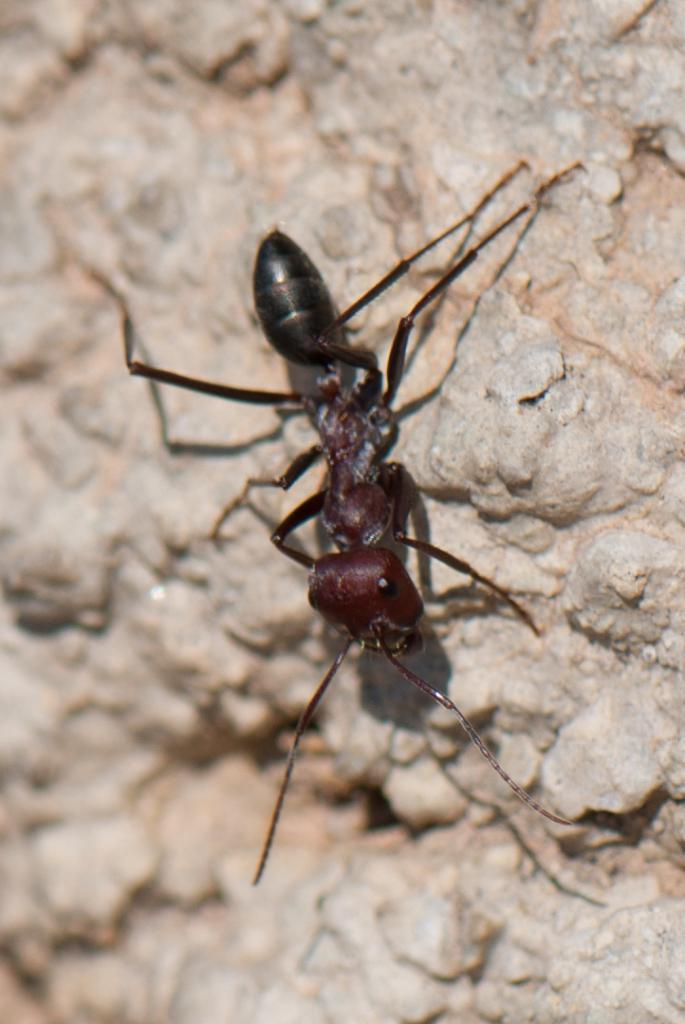What is the main subject of the image? The main subject of the image is an ant. Can you describe the ant's appearance? The ant is black in color. What can be seen in the background of the image? There is a rock or wall made up of stones in the background of the image. How is the background of the image depicted? The background of the image is blurred. What type of destruction is the grandfather causing with a hammer in the image? There is no grandfather, hammer, or destruction present in the image; it only features an ant and a blurred background. 